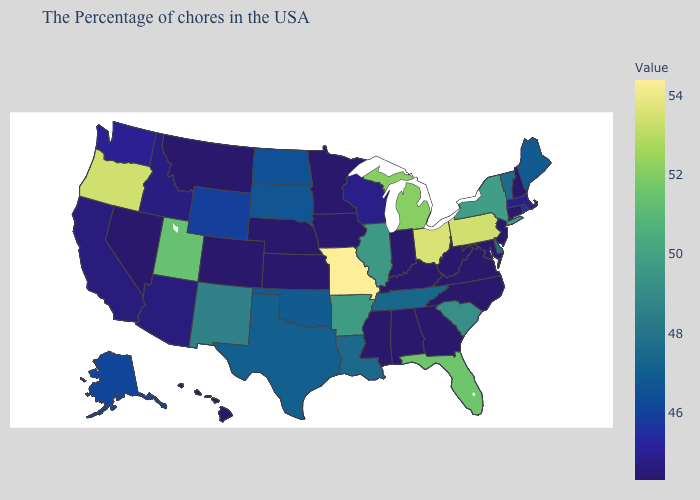Does Florida have the lowest value in the South?
Concise answer only. No. Which states have the highest value in the USA?
Keep it brief. Missouri. Does Kansas have the lowest value in the USA?
Keep it brief. Yes. Does Rhode Island have a higher value than Alabama?
Write a very short answer. Yes. Which states have the lowest value in the USA?
Concise answer only. New Hampshire, Connecticut, New Jersey, Maryland, Virginia, North Carolina, West Virginia, Georgia, Kentucky, Indiana, Alabama, Mississippi, Minnesota, Iowa, Kansas, Nebraska, Colorado, Montana, Nevada, Hawaii. Among the states that border Connecticut , does Massachusetts have the highest value?
Quick response, please. No. Does Missouri have the highest value in the USA?
Answer briefly. Yes. 